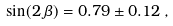<formula> <loc_0><loc_0><loc_500><loc_500>\sin ( 2 \, \beta ) = 0 . 7 9 \pm 0 . 1 2 \, ,</formula> 